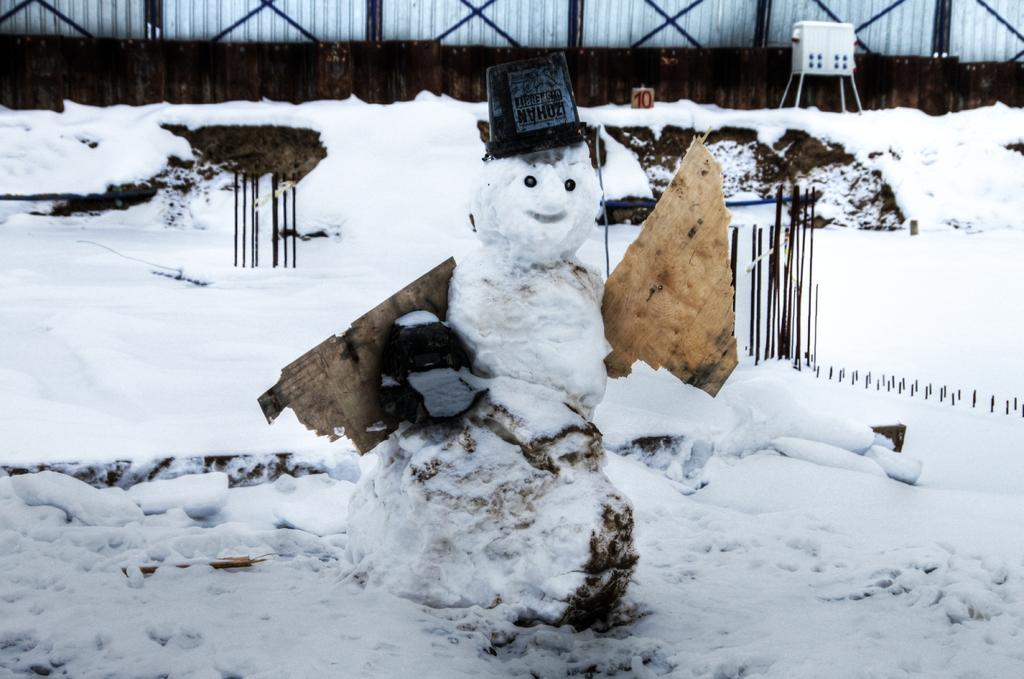What is the primary feature of the environment in the image? The image contains snow, indicating a cold or wintery environment. What objects can be seen in the image? There are rods in the image. How many cows are grazing in the snow in the image? There are no cows present in the image; it only contains snow and rods. What is the existence of the rods in the image trying to prove? The existence of the rods in the image is not trying to prove anything; they are simply objects present in the image. 